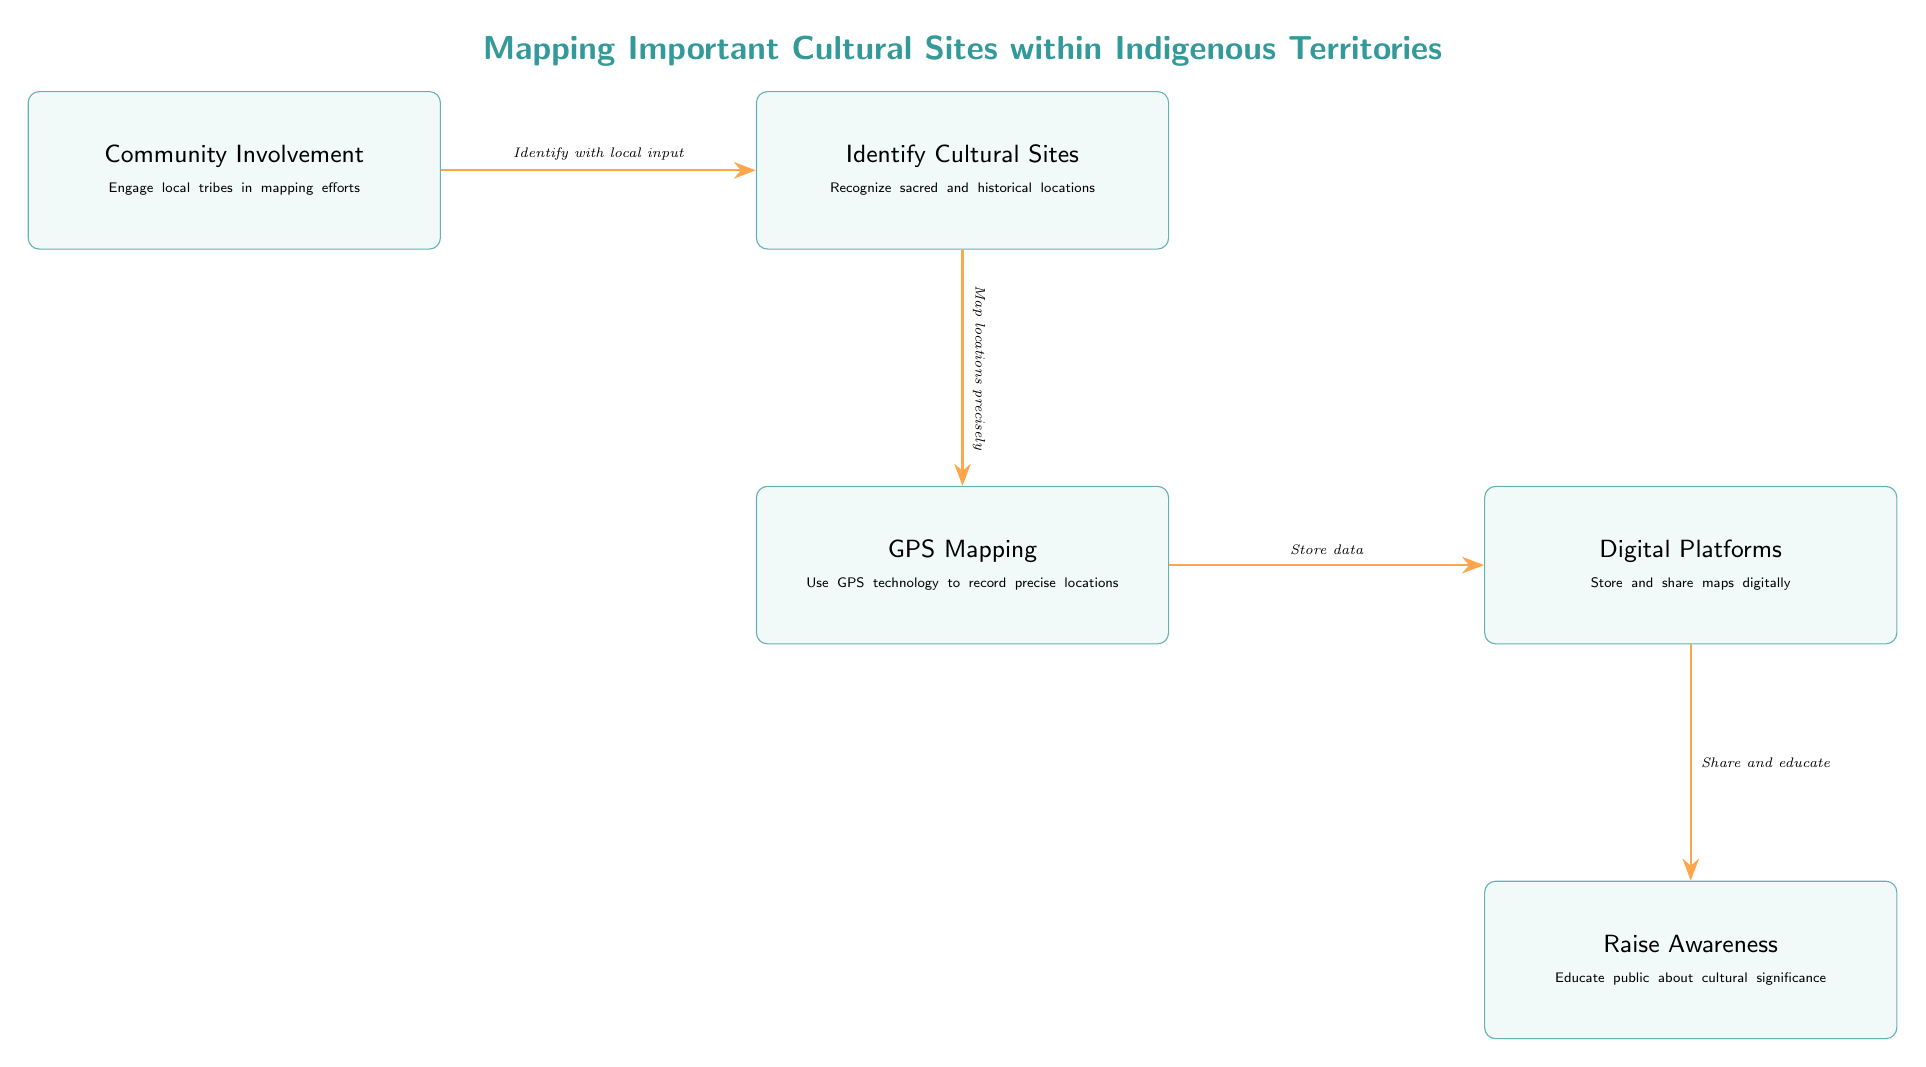What is the first step in the mapping process? The diagram indicates that the first step is "Community Involvement," which focuses on engaging local tribes.
Answer: Community Involvement How many nodes are present in the diagram? The diagram contains five nodes: Community Involvement, Identify Cultural Sites, GPS Mapping, Digital Platforms, and Raise Awareness.
Answer: 5 What is the relationship between "GPS Mapping" and "Digital Platforms"? The arrow indicates that GPS Mapping leads to Digital Platforms for storing data.
Answer: Store data Which box follows "Identify Cultural Sites"? The box that follows "Identify Cultural Sites" is "GPS Mapping."
Answer: GPS Mapping What phrase describes the purpose of "Digital Platforms"? The purpose of "Digital Platforms" is described as "Store and share maps digitally."
Answer: Store and share maps digitally What is the final action in the process outlined in the diagram? The final action is "Raise Awareness," which aims to educate the public about cultural significance.
Answer: Raise Awareness How does "Community Involvement" contribute to the identification of cultural sites? It contributes by allowing local input to identify the sites, as described in the connection to "Identify Cultural Sites."
Answer: Identify with local input In what order do the nodes progress from "GPS Mapping"? The nodes progress from GPS Mapping to Digital Platforms, then to Raise Awareness.
Answer: Digital Platforms, Raise Awareness What color is used to represent the edges connecting the boxes? The edges are drawn in orange, as indicated in the style definition for the arrows.
Answer: Orange 